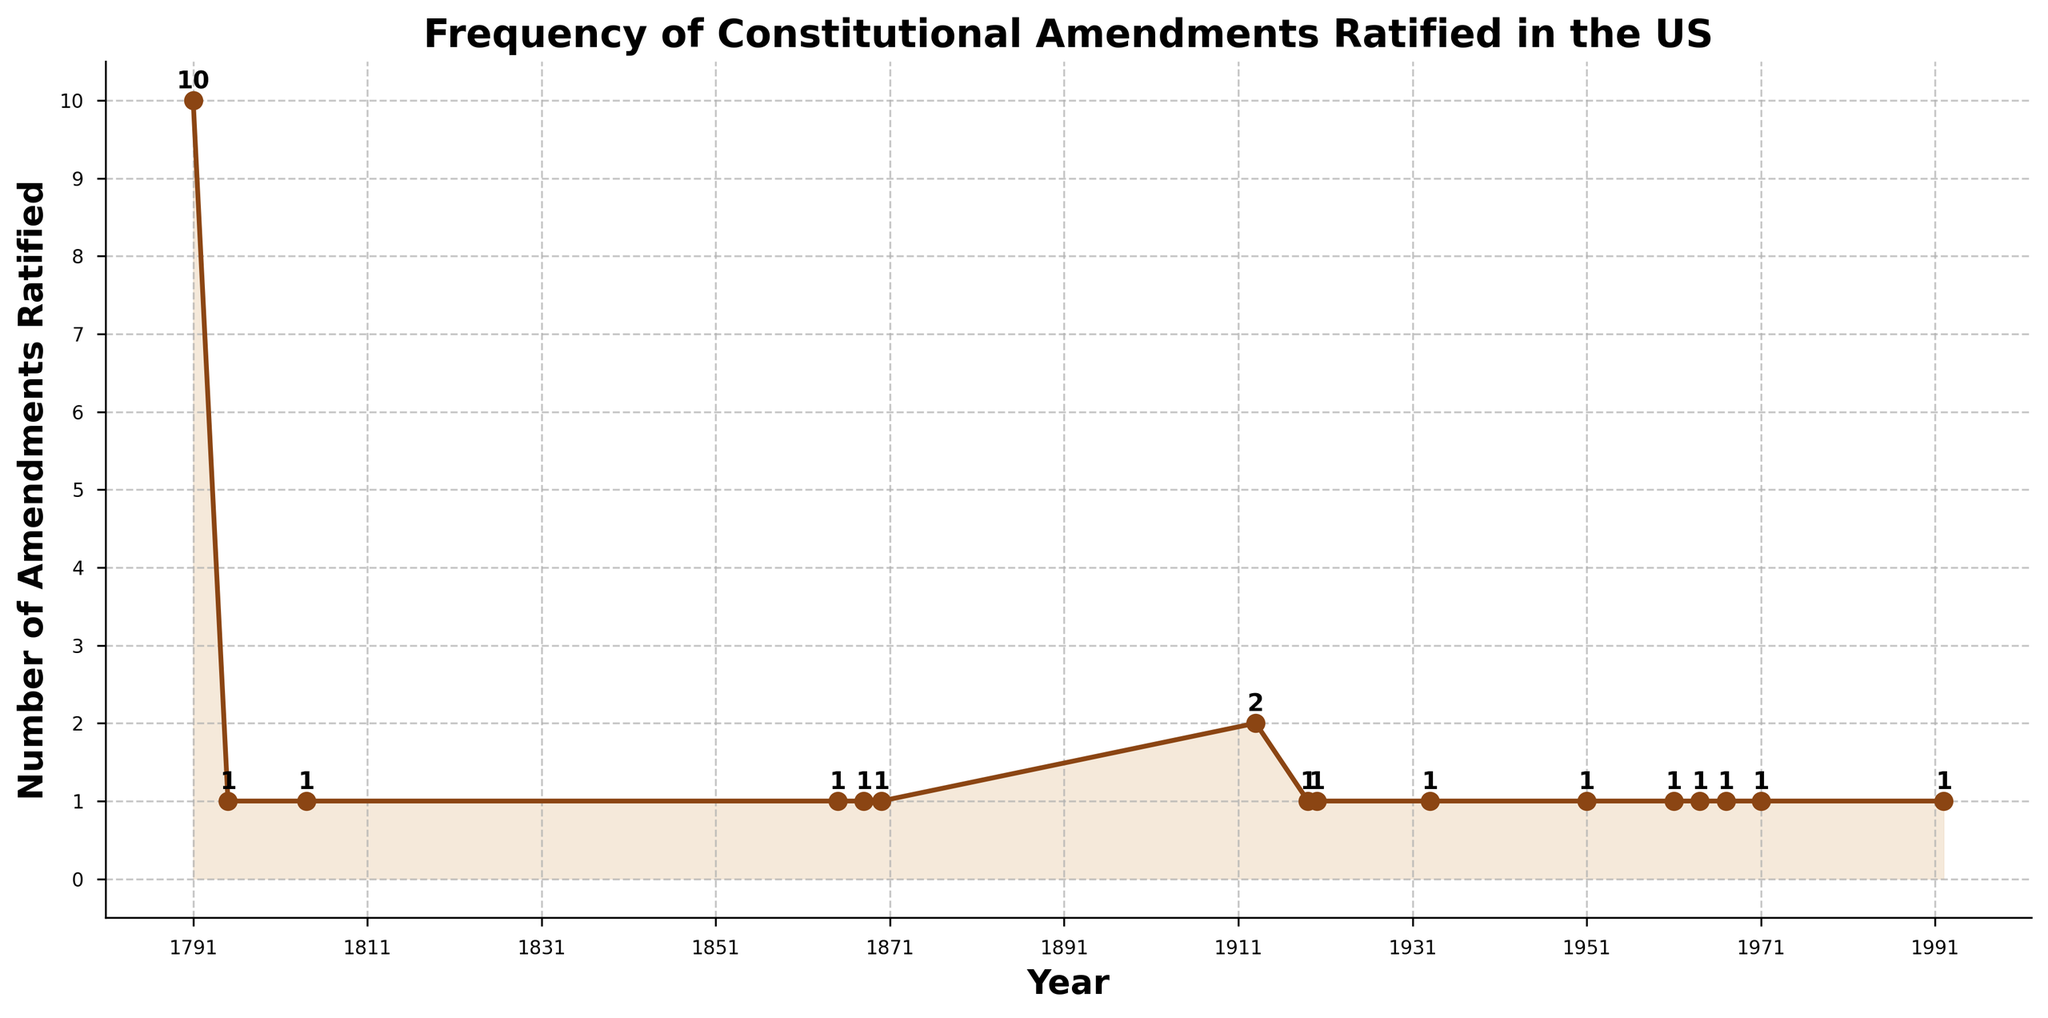Which year had the highest number of amendments ratified? To find this, look at the y-values on the chart and locate the highest value. Then, match this value to the corresponding year on the x-axis. Here, the highest number is 10, which corresponds to the year 1791.
Answer: 1791 How many amendments were ratified between 1800 and 1900? Identify the points on the line chart between 1800 and 1900. The years 1865, 1868, and 1870 each have 1 amendment ratified. Summing these up gives 1+1+1=3.
Answer: 3 Which decade saw the most amendments ratified? Look for the longest line segment on the chart for every decade. The 1790s had 10 amendments ratified, more than any other decade.
Answer: 1790s How many years had exactly one amendment ratified? Count the number of points on the line chart where the y-value equals 1. The years are 1795, 1804, 1865, 1868, 1870, 1919, 1920, 1933, 1951, 1961, 1964, 1967, 1971, and 1992. There are 14 years in total.
Answer: 14 On average, how many amendments were ratified per year between 1789 and 1992? Calculate by summing the total number of amendments ratified (27) and dividing by the number of years (1992 - 1789 + 1 = 204). 27 / 204 ≈ 0.132
Answer: Approximately 0.132 Which period saw a gap of more than 40 years without any amendments being ratified? Identify the longest gaps between points on the x-axis. The period from 1804 to 1865 is a gap of 61 years.
Answer: 1804 to 1865 Between 1910 and 1950, how many times did the number of ratified amendments equal 2? Identify the points in the time frame 1910 to 1950 where the y-value is 2. Only in 1913, 2 amendments were ratified.
Answer: 1 How many total amendments were ratified before 1900? Add the amendments ratified in each relevant year before 1900 (1791 = 10, 1795 = 1, 1804 = 1, 1865 = 1, 1868 = 1, 1870 = 1). This gives 10 + 1 + 1 + 1 + 1 + 1 = 15.
Answer: 15 What was the trend in the number of amendments ratified from 1930 to 1972? Identify the y-values from 1930 to 1972. The amendments ratified are: 1933 (1), 1951 (1), 1961 (1), 1964 (1), 1967 (1), 1971 (1). The number of amendments remained steady with 1 amendment ratified each decade.
Answer: Steady What percentage of the total amendments were ratified before 1800? Calculate the amendments ratified before 1800 (10 in 1791), divide by the total number of amendments ratified (27) and multiply by 100: (10 / 27) * 100 ≈ 37%.
Answer: Approximately 37% 